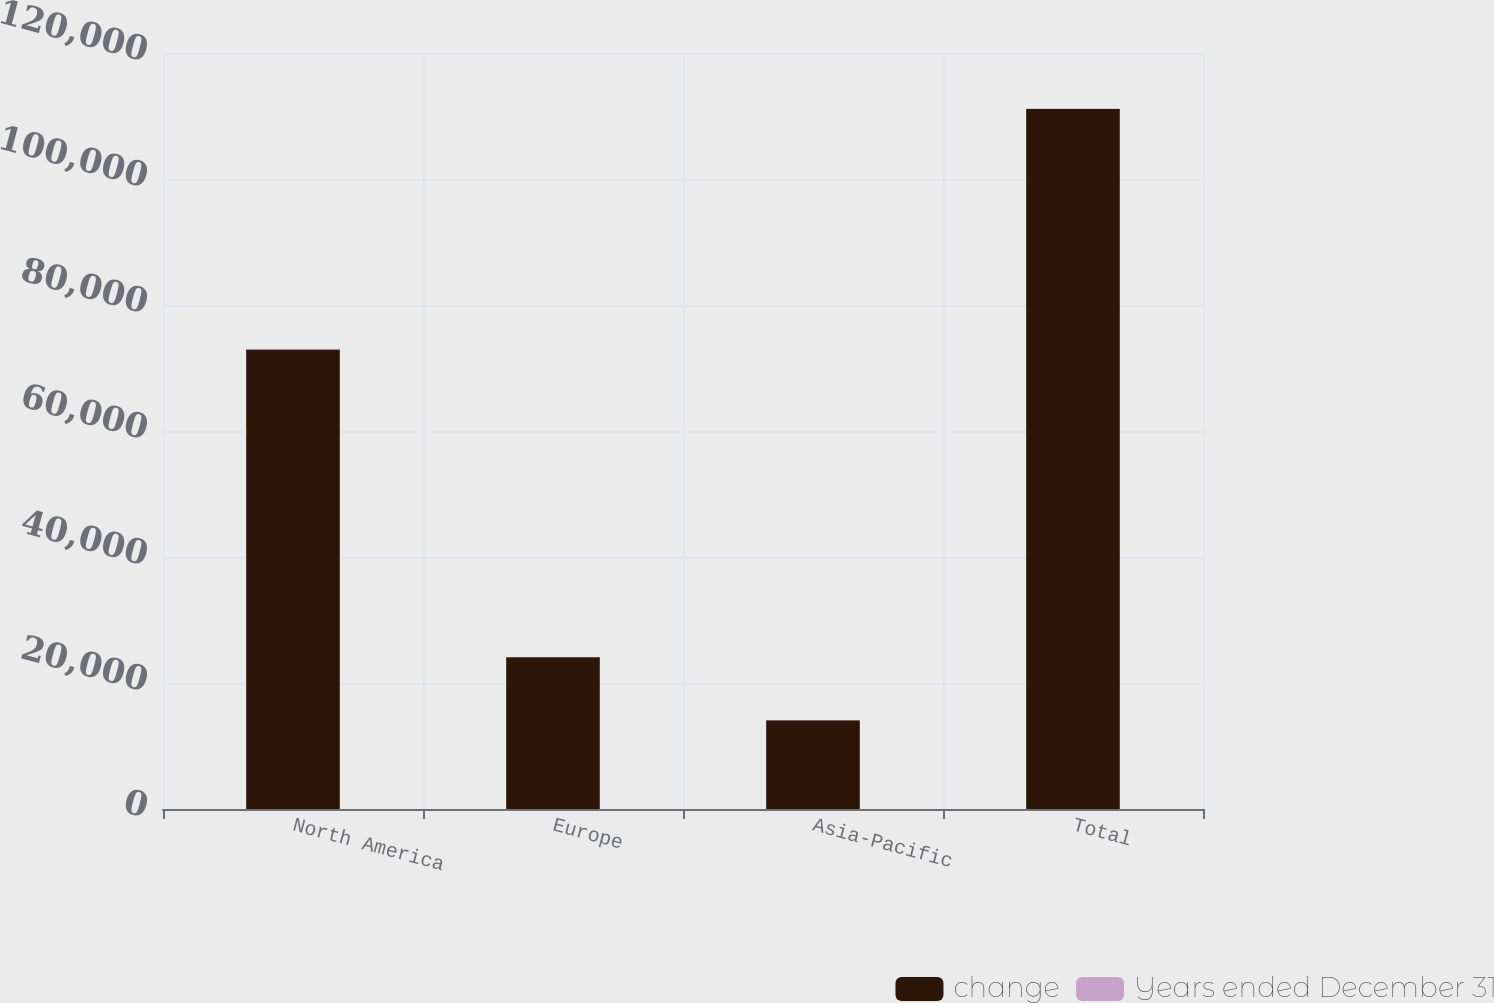Convert chart to OTSL. <chart><loc_0><loc_0><loc_500><loc_500><stacked_bar_chart><ecel><fcel>North America<fcel>Europe<fcel>Asia-Pacific<fcel>Total<nl><fcel>change<fcel>72944<fcel>24071<fcel>14089<fcel>111104<nl><fcel>Years ended December 31<fcel>103<fcel>36<fcel>42<fcel>75<nl></chart> 